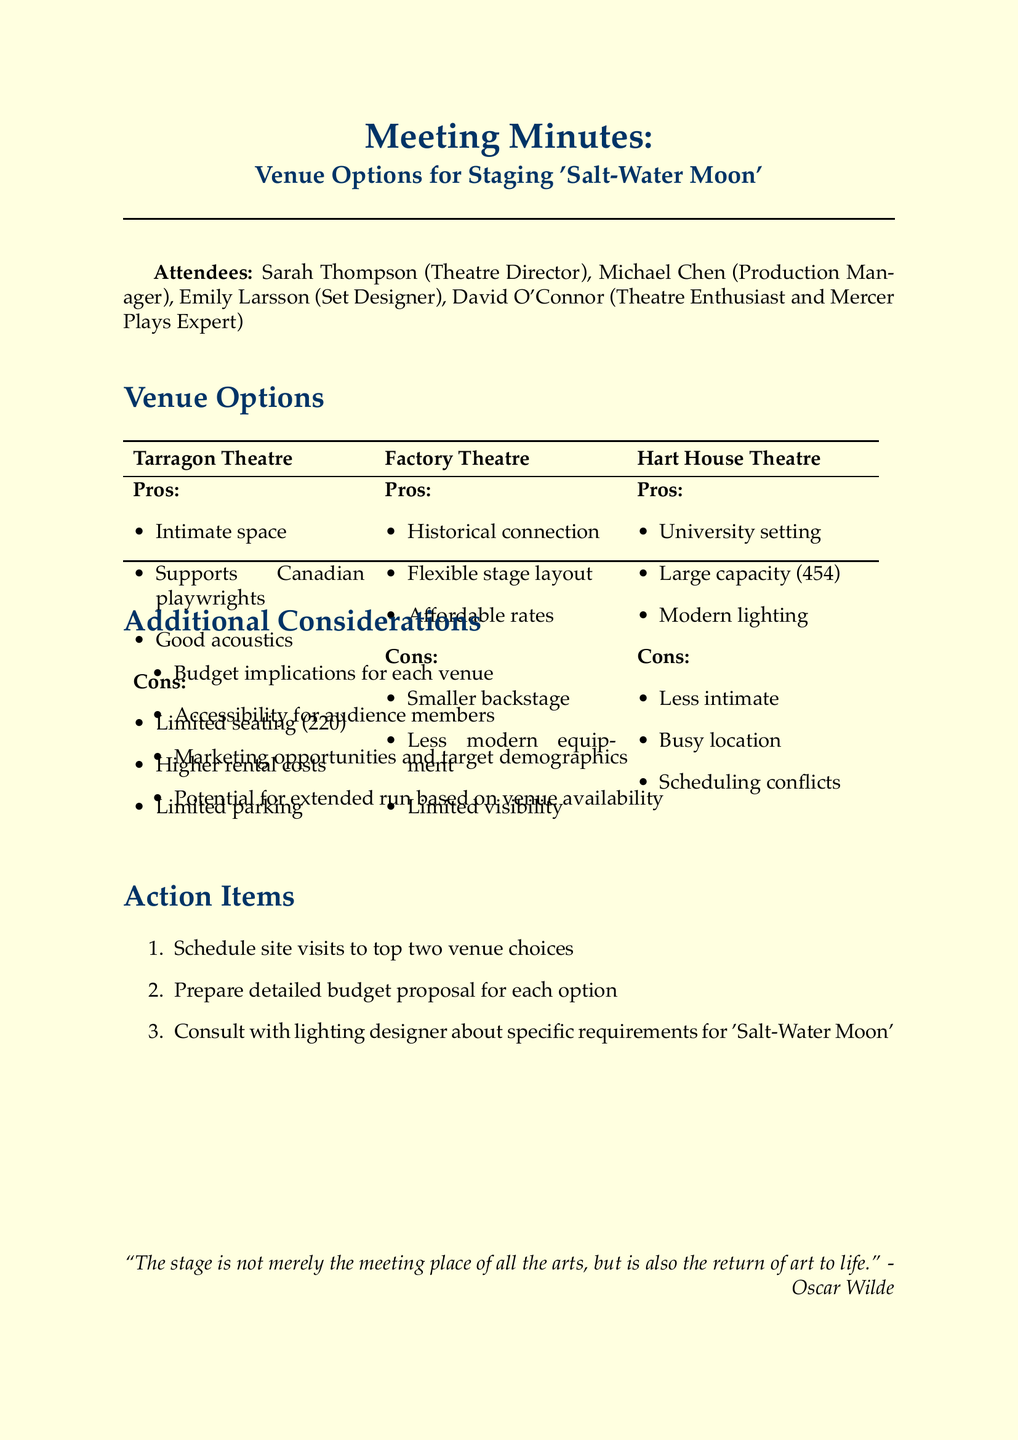What are the pros of Tarragon Theatre? The pros listed for Tarragon Theatre include an intimate space suitable for the play's setting, known for supporting Canadian playwrights, and good acoustics for dialogue-heavy scenes.
Answer: Intimate space, supports Canadian playwrights, good acoustics What is the seating capacity of Hart House Theatre? The document states that Hart House Theatre has a large seating capacity of 454 seats.
Answer: 454 seats What is a con of Factory Theatre? The document outlines that a con of Factory Theatre is its smaller backstage area.
Answer: Smaller backstage area Which action item involves consulting with a lighting designer? The action item that involves consulting with a lighting designer specifically mentions requirements for 'Salt-Water Moon'.
Answer: Consult with lighting designer about specific requirements for 'Salt-Water Moon' What is one additional consideration mentioned in the meeting? The meeting mentions various additional considerations, one of which includes accessibility for audience members.
Answer: Accessibility for audience members What is the main title of the meeting? The main title of the meeting, as indicated in the document, specifically refers to venue options for 'Salt-Water Moon'.
Answer: Venue Options for Staging 'Salt-Water Moon' What is a pro of Hart House Theatre? The document lists a pro of Hart House Theatre as having a state-of-the-art lighting system.
Answer: State-of-the-art lighting system What is the rental cost status of Factory Theatre? It is mentioned in the document that Factory Theatre has affordable rental rates.
Answer: Affordable rental rates 